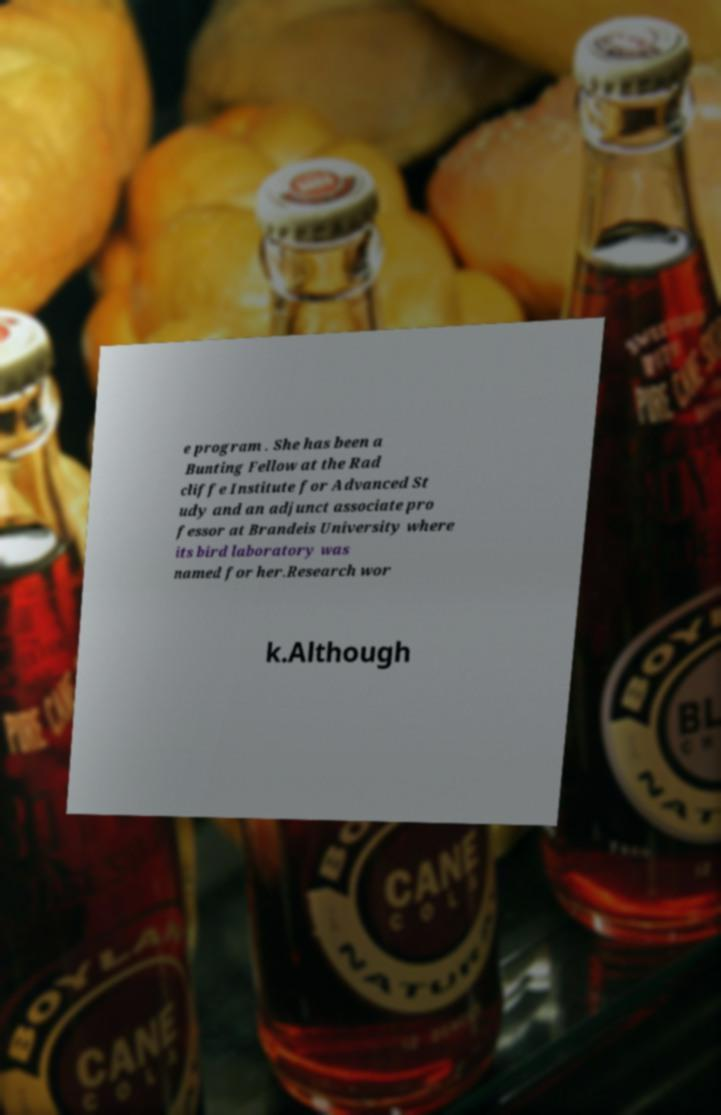Could you extract and type out the text from this image? e program . She has been a Bunting Fellow at the Rad cliffe Institute for Advanced St udy and an adjunct associate pro fessor at Brandeis University where its bird laboratory was named for her.Research wor k.Although 